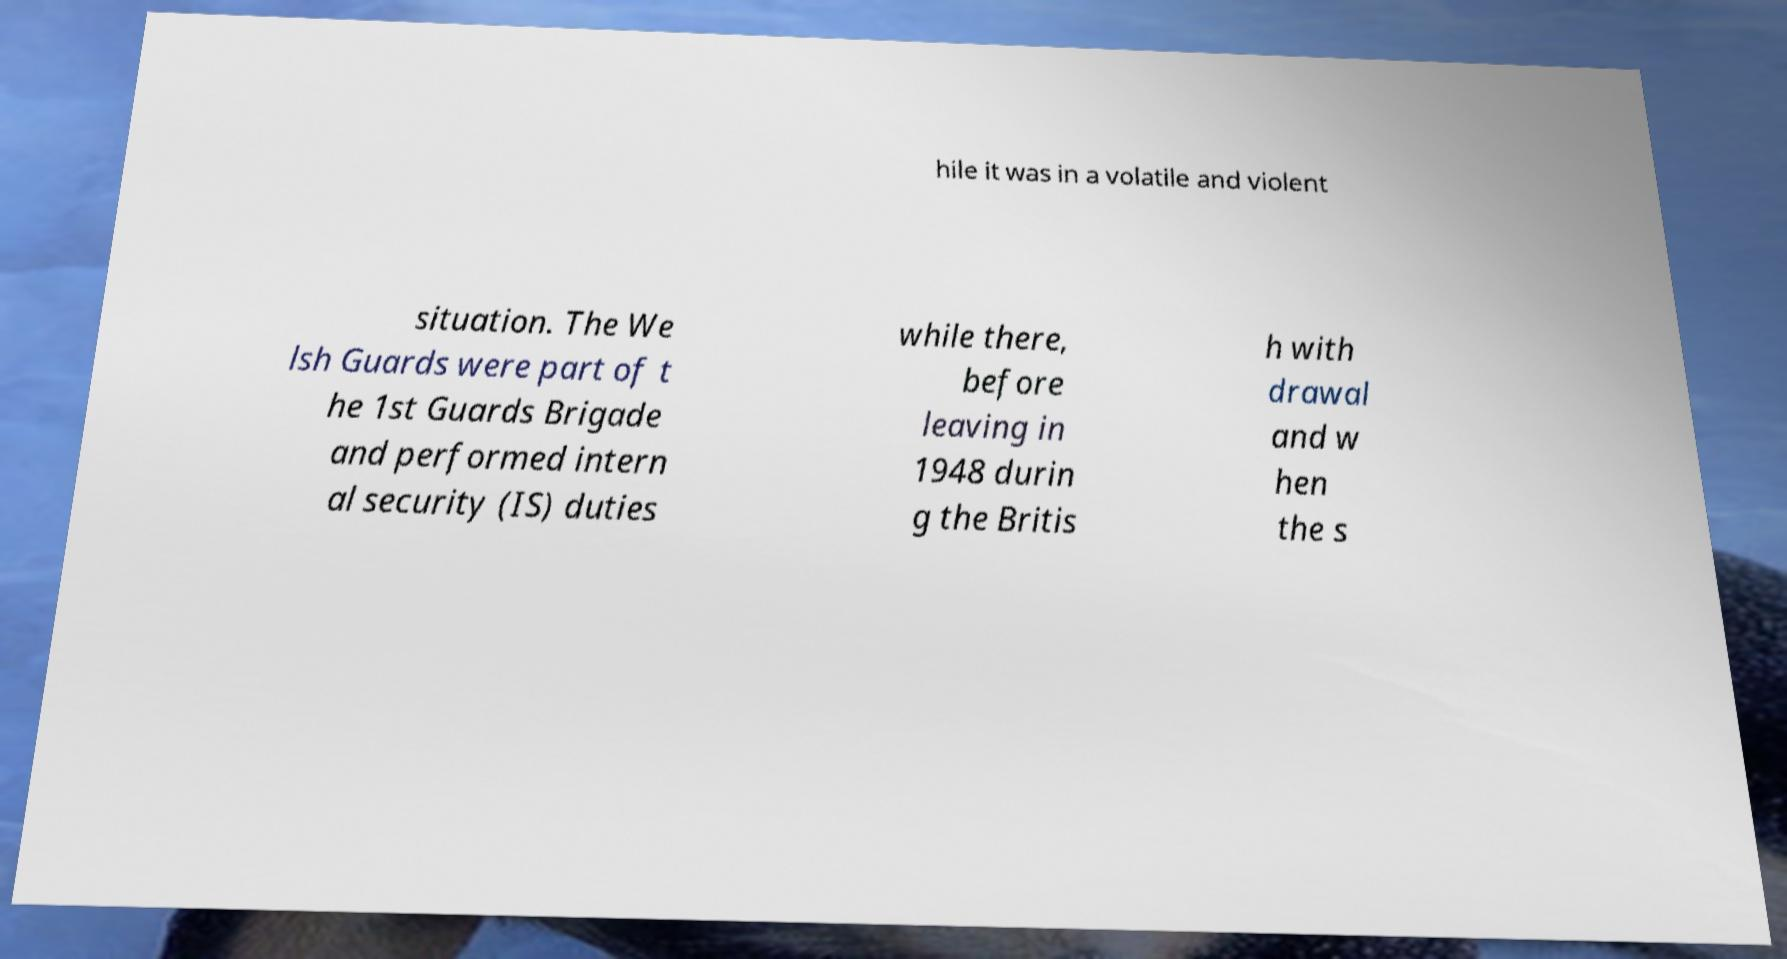There's text embedded in this image that I need extracted. Can you transcribe it verbatim? hile it was in a volatile and violent situation. The We lsh Guards were part of t he 1st Guards Brigade and performed intern al security (IS) duties while there, before leaving in 1948 durin g the Britis h with drawal and w hen the s 